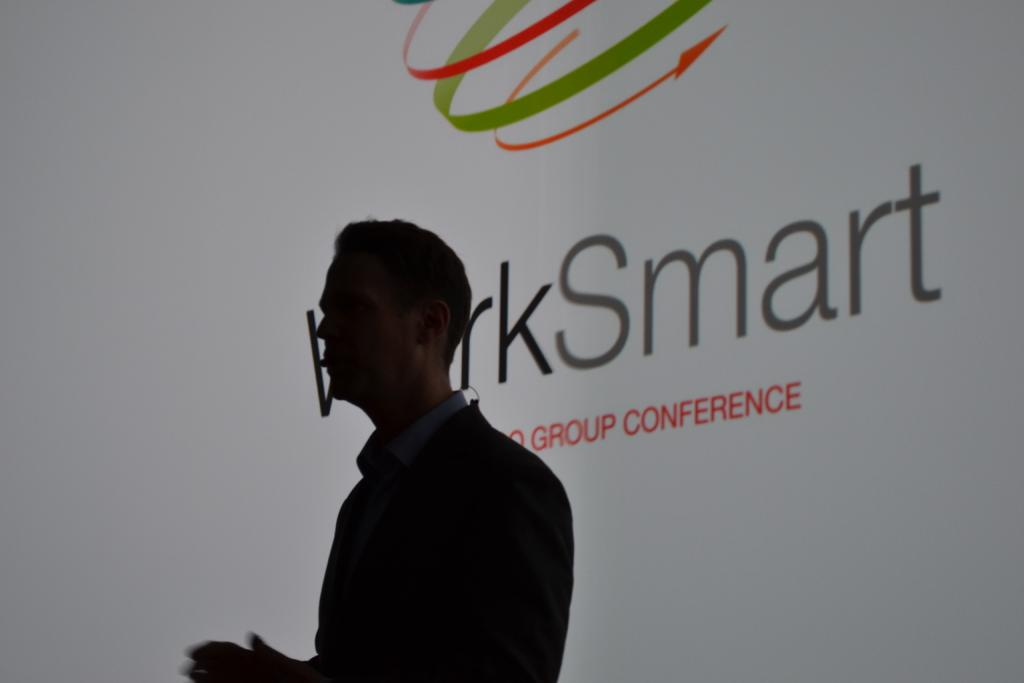What is the main subject of the image? There is a person standing in the image. Can you describe the environment in which the person is standing? The person is in a dark environment. What can be seen in the background of the image? There is a banner or projector screen in the background of the image. What is written or displayed on the banner or projector screen? The banner or projector screen has text on it. What type of toy is the person playing with in the image? There is no toy present in the image; the person is standing in a dark environment with a banner or projector screen in the background. 